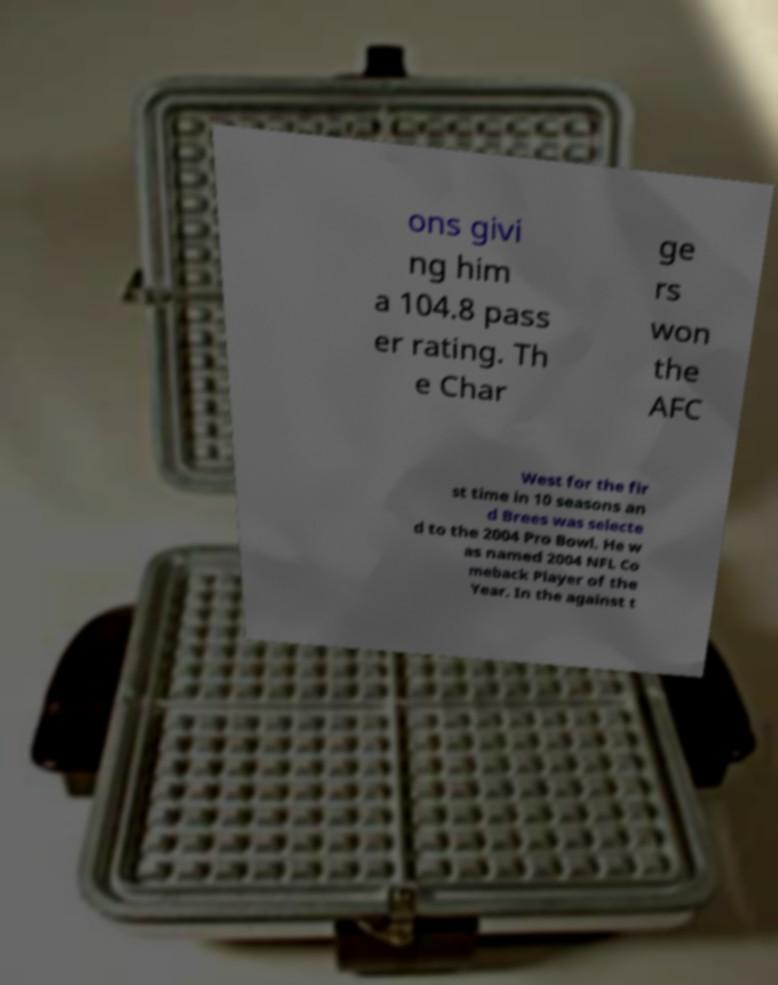Please identify and transcribe the text found in this image. ons givi ng him a 104.8 pass er rating. Th e Char ge rs won the AFC West for the fir st time in 10 seasons an d Brees was selecte d to the 2004 Pro Bowl. He w as named 2004 NFL Co meback Player of the Year. In the against t 